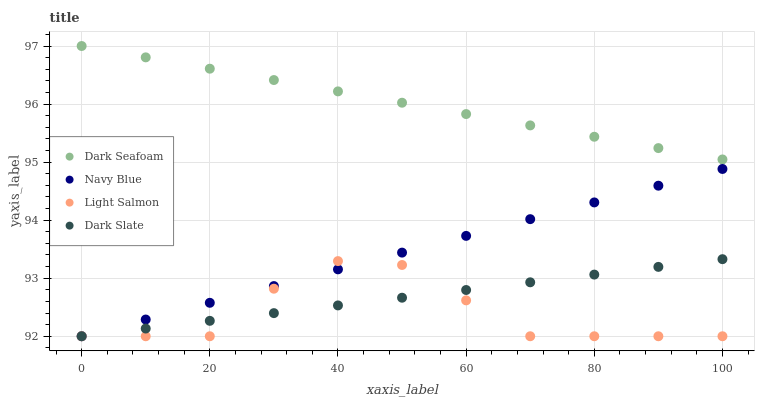Does Light Salmon have the minimum area under the curve?
Answer yes or no. Yes. Does Dark Seafoam have the maximum area under the curve?
Answer yes or no. Yes. Does Dark Seafoam have the minimum area under the curve?
Answer yes or no. No. Does Light Salmon have the maximum area under the curve?
Answer yes or no. No. Is Dark Seafoam the smoothest?
Answer yes or no. Yes. Is Light Salmon the roughest?
Answer yes or no. Yes. Is Light Salmon the smoothest?
Answer yes or no. No. Is Dark Seafoam the roughest?
Answer yes or no. No. Does Navy Blue have the lowest value?
Answer yes or no. Yes. Does Dark Seafoam have the lowest value?
Answer yes or no. No. Does Dark Seafoam have the highest value?
Answer yes or no. Yes. Does Light Salmon have the highest value?
Answer yes or no. No. Is Navy Blue less than Dark Seafoam?
Answer yes or no. Yes. Is Dark Seafoam greater than Navy Blue?
Answer yes or no. Yes. Does Dark Slate intersect Navy Blue?
Answer yes or no. Yes. Is Dark Slate less than Navy Blue?
Answer yes or no. No. Is Dark Slate greater than Navy Blue?
Answer yes or no. No. Does Navy Blue intersect Dark Seafoam?
Answer yes or no. No. 